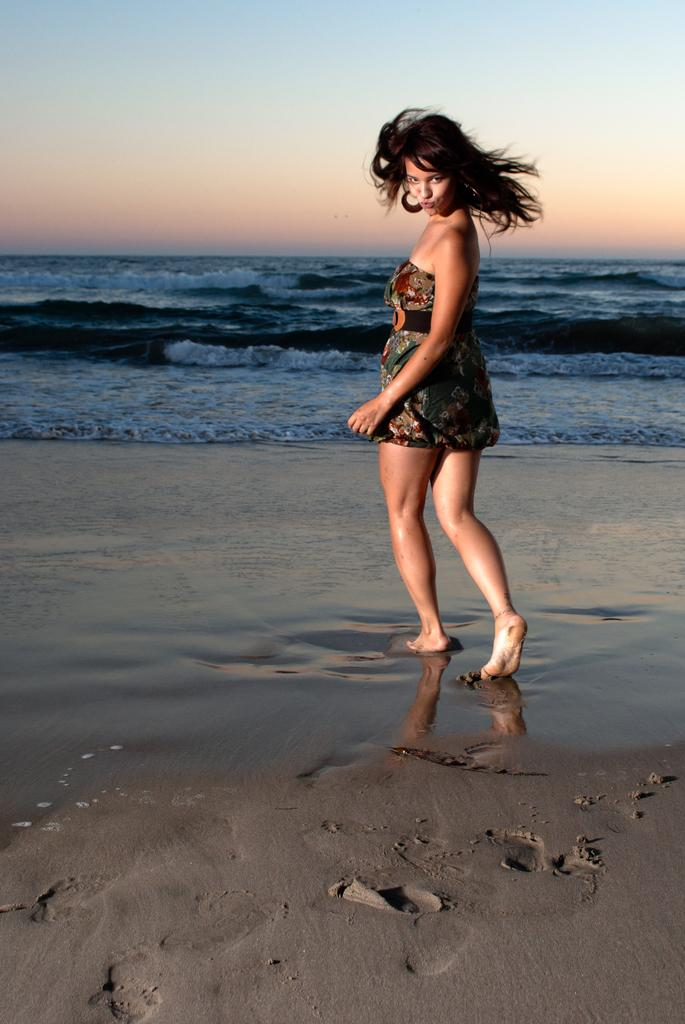Who is the main subject in the image? There is a girl in the image. Where is the girl located in the image? The girl is standing on the beach. What is the girl doing in the image? The girl is posing for the camera. What can be seen in the background of the image? There is sea water visible in the image, and the sky is showing a sunset. What type of crime is being committed on the beach in the image? There is no crime being committed in the image; it shows a girl posing for the camera on the beach during a sunset. 